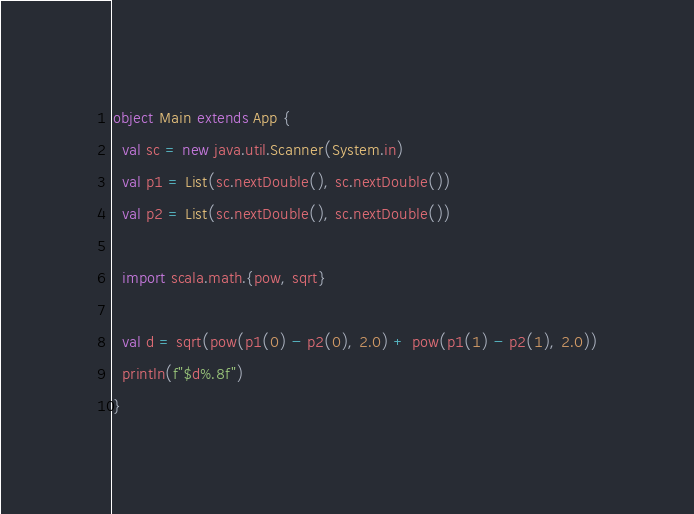<code> <loc_0><loc_0><loc_500><loc_500><_Scala_>object Main extends App {
  val sc = new java.util.Scanner(System.in)
  val p1 = List(sc.nextDouble(), sc.nextDouble())
  val p2 = List(sc.nextDouble(), sc.nextDouble())

  import scala.math.{pow, sqrt}

  val d = sqrt(pow(p1(0) - p2(0), 2.0) + pow(p1(1) - p2(1), 2.0))
  println(f"$d%.8f")
}</code> 